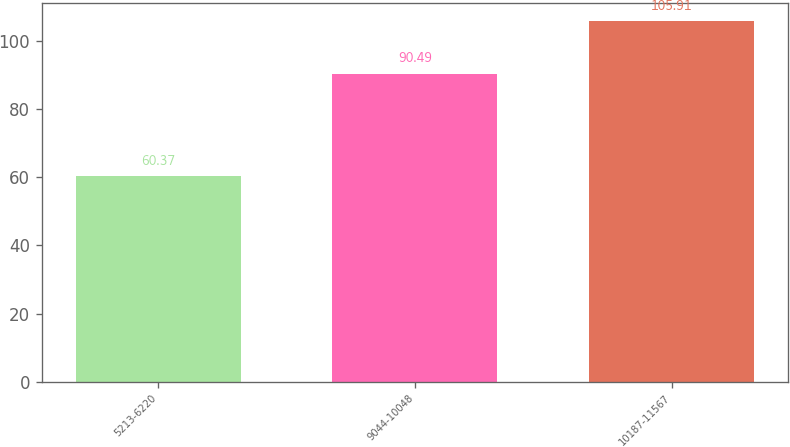Convert chart. <chart><loc_0><loc_0><loc_500><loc_500><bar_chart><fcel>5213-6220<fcel>9044-10048<fcel>10187-11567<nl><fcel>60.37<fcel>90.49<fcel>105.91<nl></chart> 